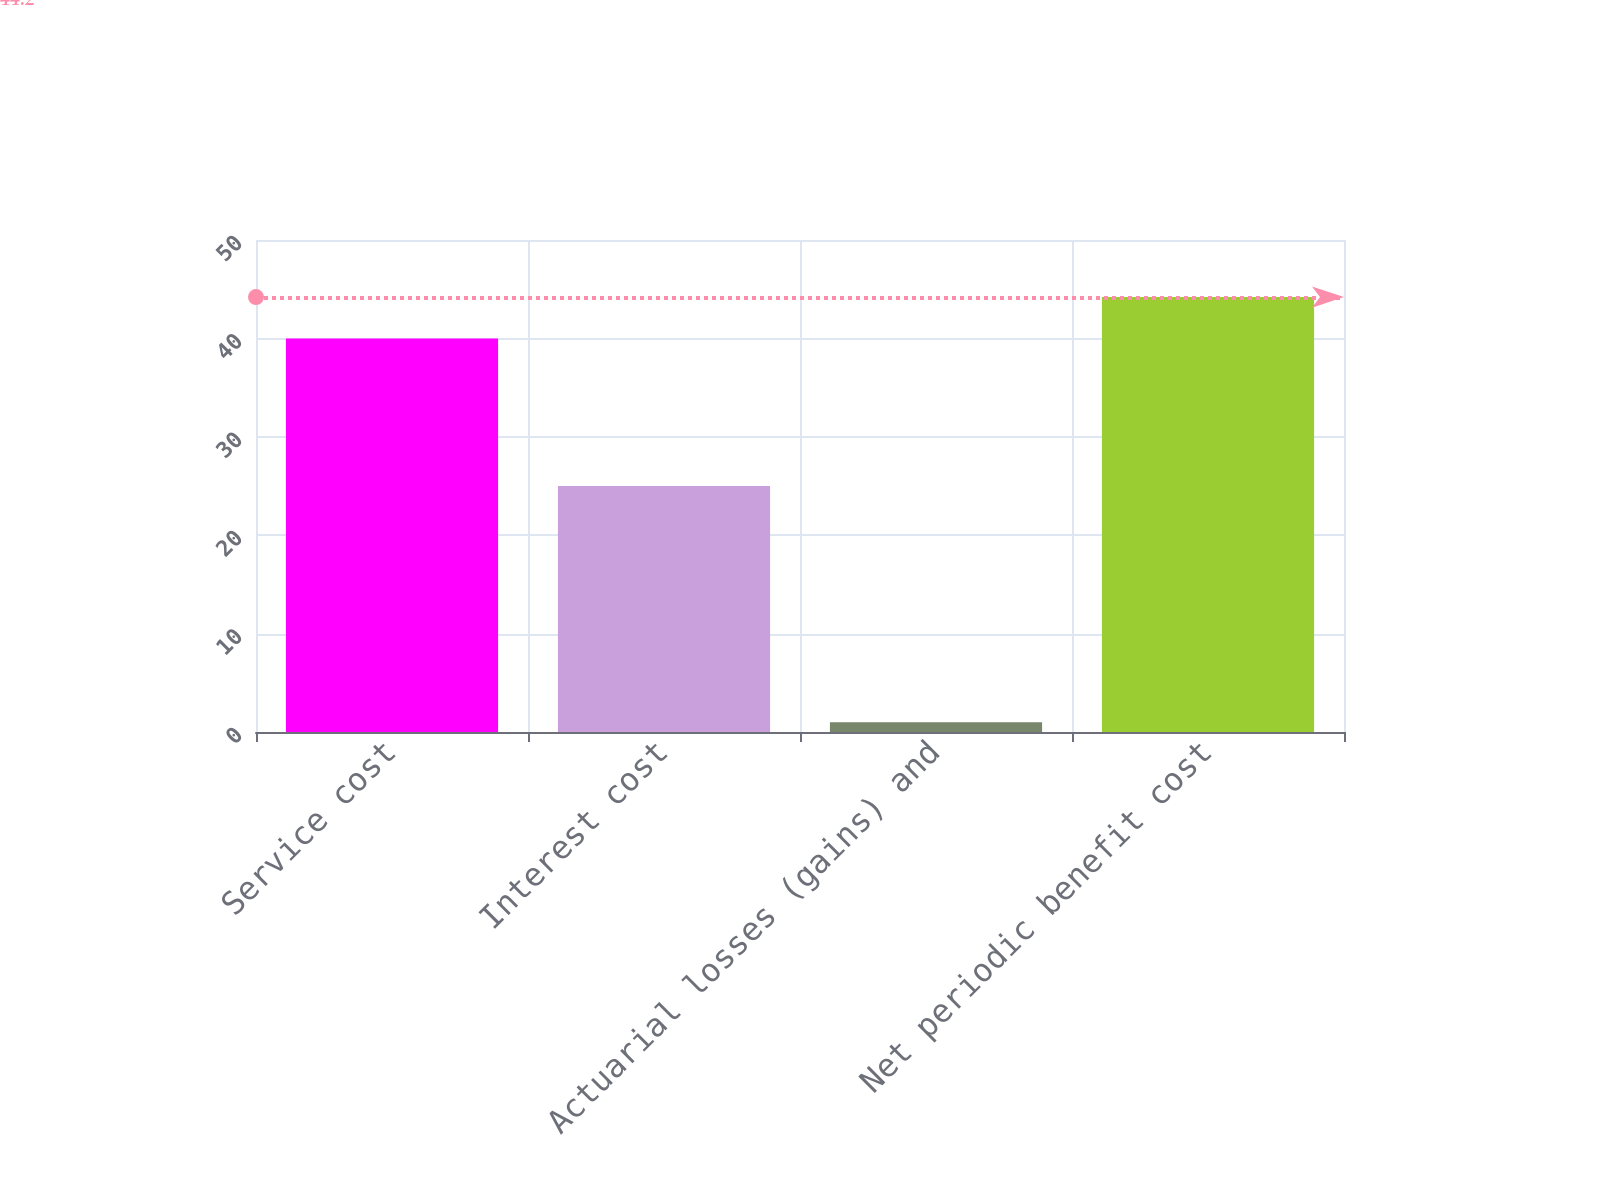<chart> <loc_0><loc_0><loc_500><loc_500><bar_chart><fcel>Service cost<fcel>Interest cost<fcel>Actuarial losses (gains) and<fcel>Net periodic benefit cost<nl><fcel>40<fcel>25<fcel>1<fcel>44.2<nl></chart> 